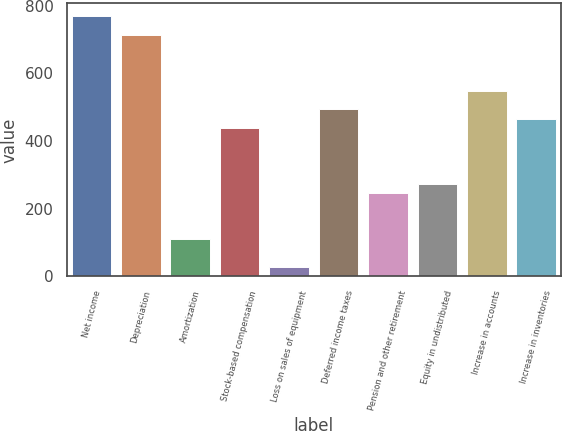<chart> <loc_0><loc_0><loc_500><loc_500><bar_chart><fcel>Net income<fcel>Depreciation<fcel>Amortization<fcel>Stock-based compensation<fcel>Loss on sales of equipment<fcel>Deferred income taxes<fcel>Pension and other retirement<fcel>Equity in undistributed<fcel>Increase in accounts<fcel>Increase in inventories<nl><fcel>768.34<fcel>713.48<fcel>110.02<fcel>439.18<fcel>27.73<fcel>494.04<fcel>247.17<fcel>274.6<fcel>548.9<fcel>466.61<nl></chart> 